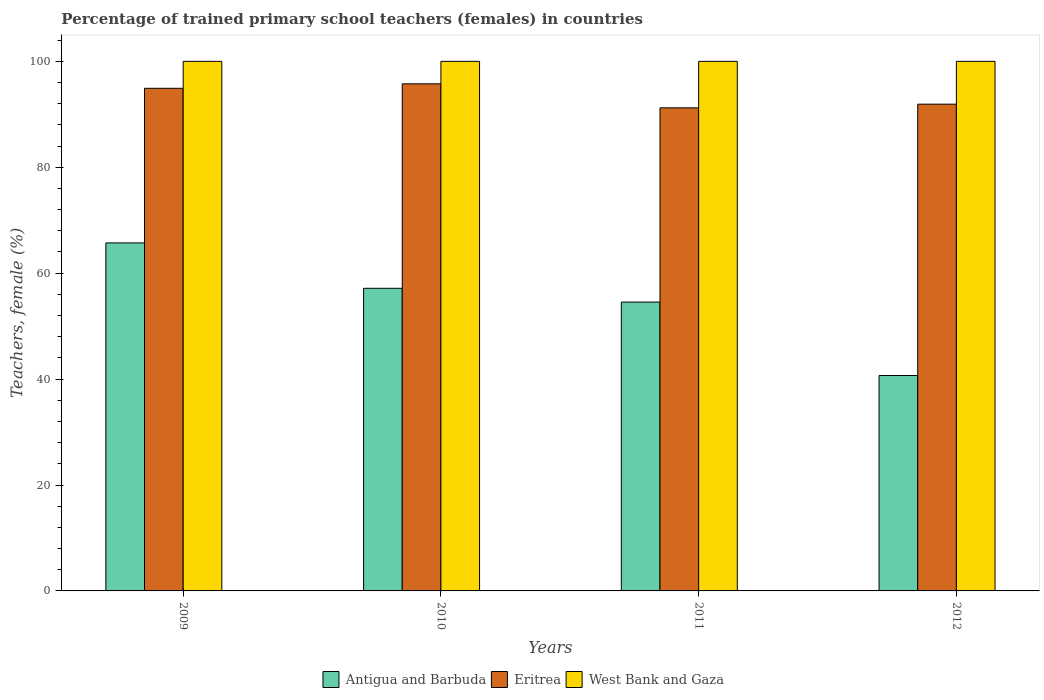How many different coloured bars are there?
Make the answer very short. 3. How many groups of bars are there?
Give a very brief answer. 4. How many bars are there on the 1st tick from the left?
Your answer should be very brief. 3. What is the label of the 1st group of bars from the left?
Your answer should be very brief. 2009. In how many cases, is the number of bars for a given year not equal to the number of legend labels?
Offer a terse response. 0. What is the percentage of trained primary school teachers (females) in Antigua and Barbuda in 2009?
Keep it short and to the point. 65.71. Across all years, what is the maximum percentage of trained primary school teachers (females) in Eritrea?
Offer a very short reply. 95.76. Across all years, what is the minimum percentage of trained primary school teachers (females) in Eritrea?
Give a very brief answer. 91.22. In which year was the percentage of trained primary school teachers (females) in Eritrea minimum?
Provide a short and direct response. 2011. What is the difference between the percentage of trained primary school teachers (females) in Antigua and Barbuda in 2010 and that in 2011?
Offer a very short reply. 2.6. What is the difference between the percentage of trained primary school teachers (females) in Eritrea in 2011 and the percentage of trained primary school teachers (females) in West Bank and Gaza in 2009?
Your response must be concise. -8.78. What is the average percentage of trained primary school teachers (females) in Antigua and Barbuda per year?
Make the answer very short. 54.52. In the year 2012, what is the difference between the percentage of trained primary school teachers (females) in Antigua and Barbuda and percentage of trained primary school teachers (females) in West Bank and Gaza?
Provide a short and direct response. -59.32. What is the ratio of the percentage of trained primary school teachers (females) in West Bank and Gaza in 2011 to that in 2012?
Provide a short and direct response. 1. Is the difference between the percentage of trained primary school teachers (females) in Antigua and Barbuda in 2011 and 2012 greater than the difference between the percentage of trained primary school teachers (females) in West Bank and Gaza in 2011 and 2012?
Your answer should be very brief. Yes. What is the difference between the highest and the second highest percentage of trained primary school teachers (females) in Antigua and Barbuda?
Ensure brevity in your answer.  8.57. What is the difference between the highest and the lowest percentage of trained primary school teachers (females) in Antigua and Barbuda?
Make the answer very short. 25.04. In how many years, is the percentage of trained primary school teachers (females) in Antigua and Barbuda greater than the average percentage of trained primary school teachers (females) in Antigua and Barbuda taken over all years?
Ensure brevity in your answer.  3. What does the 2nd bar from the left in 2010 represents?
Make the answer very short. Eritrea. What does the 1st bar from the right in 2009 represents?
Offer a very short reply. West Bank and Gaza. Is it the case that in every year, the sum of the percentage of trained primary school teachers (females) in West Bank and Gaza and percentage of trained primary school teachers (females) in Antigua and Barbuda is greater than the percentage of trained primary school teachers (females) in Eritrea?
Make the answer very short. Yes. How many bars are there?
Your response must be concise. 12. Are all the bars in the graph horizontal?
Offer a very short reply. No. How many years are there in the graph?
Offer a very short reply. 4. What is the difference between two consecutive major ticks on the Y-axis?
Offer a terse response. 20. Does the graph contain grids?
Give a very brief answer. No. How many legend labels are there?
Give a very brief answer. 3. How are the legend labels stacked?
Your answer should be very brief. Horizontal. What is the title of the graph?
Make the answer very short. Percentage of trained primary school teachers (females) in countries. What is the label or title of the X-axis?
Ensure brevity in your answer.  Years. What is the label or title of the Y-axis?
Make the answer very short. Teachers, female (%). What is the Teachers, female (%) in Antigua and Barbuda in 2009?
Ensure brevity in your answer.  65.71. What is the Teachers, female (%) of Eritrea in 2009?
Your answer should be compact. 94.91. What is the Teachers, female (%) in Antigua and Barbuda in 2010?
Ensure brevity in your answer.  57.14. What is the Teachers, female (%) of Eritrea in 2010?
Provide a short and direct response. 95.76. What is the Teachers, female (%) in Antigua and Barbuda in 2011?
Your response must be concise. 54.55. What is the Teachers, female (%) in Eritrea in 2011?
Provide a succinct answer. 91.22. What is the Teachers, female (%) in West Bank and Gaza in 2011?
Your answer should be compact. 100. What is the Teachers, female (%) in Antigua and Barbuda in 2012?
Your answer should be compact. 40.68. What is the Teachers, female (%) in Eritrea in 2012?
Offer a terse response. 91.91. Across all years, what is the maximum Teachers, female (%) of Antigua and Barbuda?
Offer a very short reply. 65.71. Across all years, what is the maximum Teachers, female (%) of Eritrea?
Provide a succinct answer. 95.76. Across all years, what is the maximum Teachers, female (%) of West Bank and Gaza?
Provide a succinct answer. 100. Across all years, what is the minimum Teachers, female (%) of Antigua and Barbuda?
Make the answer very short. 40.68. Across all years, what is the minimum Teachers, female (%) in Eritrea?
Provide a short and direct response. 91.22. Across all years, what is the minimum Teachers, female (%) of West Bank and Gaza?
Offer a very short reply. 100. What is the total Teachers, female (%) in Antigua and Barbuda in the graph?
Keep it short and to the point. 218.08. What is the total Teachers, female (%) in Eritrea in the graph?
Offer a very short reply. 373.81. What is the total Teachers, female (%) in West Bank and Gaza in the graph?
Your answer should be very brief. 400. What is the difference between the Teachers, female (%) of Antigua and Barbuda in 2009 and that in 2010?
Your answer should be very brief. 8.57. What is the difference between the Teachers, female (%) in Eritrea in 2009 and that in 2010?
Offer a very short reply. -0.85. What is the difference between the Teachers, female (%) in West Bank and Gaza in 2009 and that in 2010?
Offer a very short reply. 0. What is the difference between the Teachers, female (%) in Antigua and Barbuda in 2009 and that in 2011?
Your response must be concise. 11.17. What is the difference between the Teachers, female (%) in Eritrea in 2009 and that in 2011?
Keep it short and to the point. 3.69. What is the difference between the Teachers, female (%) in Antigua and Barbuda in 2009 and that in 2012?
Give a very brief answer. 25.04. What is the difference between the Teachers, female (%) of Eritrea in 2009 and that in 2012?
Make the answer very short. 3. What is the difference between the Teachers, female (%) in Antigua and Barbuda in 2010 and that in 2011?
Provide a succinct answer. 2.6. What is the difference between the Teachers, female (%) in Eritrea in 2010 and that in 2011?
Make the answer very short. 4.54. What is the difference between the Teachers, female (%) of Antigua and Barbuda in 2010 and that in 2012?
Provide a succinct answer. 16.46. What is the difference between the Teachers, female (%) of Eritrea in 2010 and that in 2012?
Offer a very short reply. 3.84. What is the difference between the Teachers, female (%) in West Bank and Gaza in 2010 and that in 2012?
Offer a very short reply. 0. What is the difference between the Teachers, female (%) of Antigua and Barbuda in 2011 and that in 2012?
Your answer should be very brief. 13.87. What is the difference between the Teachers, female (%) of Eritrea in 2011 and that in 2012?
Give a very brief answer. -0.69. What is the difference between the Teachers, female (%) of Antigua and Barbuda in 2009 and the Teachers, female (%) of Eritrea in 2010?
Give a very brief answer. -30.04. What is the difference between the Teachers, female (%) in Antigua and Barbuda in 2009 and the Teachers, female (%) in West Bank and Gaza in 2010?
Make the answer very short. -34.29. What is the difference between the Teachers, female (%) of Eritrea in 2009 and the Teachers, female (%) of West Bank and Gaza in 2010?
Make the answer very short. -5.09. What is the difference between the Teachers, female (%) of Antigua and Barbuda in 2009 and the Teachers, female (%) of Eritrea in 2011?
Provide a short and direct response. -25.51. What is the difference between the Teachers, female (%) in Antigua and Barbuda in 2009 and the Teachers, female (%) in West Bank and Gaza in 2011?
Offer a terse response. -34.29. What is the difference between the Teachers, female (%) in Eritrea in 2009 and the Teachers, female (%) in West Bank and Gaza in 2011?
Your response must be concise. -5.09. What is the difference between the Teachers, female (%) in Antigua and Barbuda in 2009 and the Teachers, female (%) in Eritrea in 2012?
Provide a succinct answer. -26.2. What is the difference between the Teachers, female (%) of Antigua and Barbuda in 2009 and the Teachers, female (%) of West Bank and Gaza in 2012?
Give a very brief answer. -34.29. What is the difference between the Teachers, female (%) of Eritrea in 2009 and the Teachers, female (%) of West Bank and Gaza in 2012?
Keep it short and to the point. -5.09. What is the difference between the Teachers, female (%) of Antigua and Barbuda in 2010 and the Teachers, female (%) of Eritrea in 2011?
Ensure brevity in your answer.  -34.08. What is the difference between the Teachers, female (%) in Antigua and Barbuda in 2010 and the Teachers, female (%) in West Bank and Gaza in 2011?
Give a very brief answer. -42.86. What is the difference between the Teachers, female (%) of Eritrea in 2010 and the Teachers, female (%) of West Bank and Gaza in 2011?
Your answer should be very brief. -4.24. What is the difference between the Teachers, female (%) in Antigua and Barbuda in 2010 and the Teachers, female (%) in Eritrea in 2012?
Offer a terse response. -34.77. What is the difference between the Teachers, female (%) in Antigua and Barbuda in 2010 and the Teachers, female (%) in West Bank and Gaza in 2012?
Give a very brief answer. -42.86. What is the difference between the Teachers, female (%) in Eritrea in 2010 and the Teachers, female (%) in West Bank and Gaza in 2012?
Make the answer very short. -4.24. What is the difference between the Teachers, female (%) in Antigua and Barbuda in 2011 and the Teachers, female (%) in Eritrea in 2012?
Your answer should be compact. -37.37. What is the difference between the Teachers, female (%) of Antigua and Barbuda in 2011 and the Teachers, female (%) of West Bank and Gaza in 2012?
Give a very brief answer. -45.45. What is the difference between the Teachers, female (%) in Eritrea in 2011 and the Teachers, female (%) in West Bank and Gaza in 2012?
Your answer should be very brief. -8.78. What is the average Teachers, female (%) in Antigua and Barbuda per year?
Your answer should be compact. 54.52. What is the average Teachers, female (%) of Eritrea per year?
Your answer should be compact. 93.45. In the year 2009, what is the difference between the Teachers, female (%) in Antigua and Barbuda and Teachers, female (%) in Eritrea?
Keep it short and to the point. -29.2. In the year 2009, what is the difference between the Teachers, female (%) of Antigua and Barbuda and Teachers, female (%) of West Bank and Gaza?
Your response must be concise. -34.29. In the year 2009, what is the difference between the Teachers, female (%) in Eritrea and Teachers, female (%) in West Bank and Gaza?
Your response must be concise. -5.09. In the year 2010, what is the difference between the Teachers, female (%) of Antigua and Barbuda and Teachers, female (%) of Eritrea?
Your answer should be compact. -38.62. In the year 2010, what is the difference between the Teachers, female (%) in Antigua and Barbuda and Teachers, female (%) in West Bank and Gaza?
Ensure brevity in your answer.  -42.86. In the year 2010, what is the difference between the Teachers, female (%) of Eritrea and Teachers, female (%) of West Bank and Gaza?
Keep it short and to the point. -4.24. In the year 2011, what is the difference between the Teachers, female (%) of Antigua and Barbuda and Teachers, female (%) of Eritrea?
Provide a short and direct response. -36.68. In the year 2011, what is the difference between the Teachers, female (%) in Antigua and Barbuda and Teachers, female (%) in West Bank and Gaza?
Your response must be concise. -45.45. In the year 2011, what is the difference between the Teachers, female (%) of Eritrea and Teachers, female (%) of West Bank and Gaza?
Your response must be concise. -8.78. In the year 2012, what is the difference between the Teachers, female (%) in Antigua and Barbuda and Teachers, female (%) in Eritrea?
Make the answer very short. -51.24. In the year 2012, what is the difference between the Teachers, female (%) in Antigua and Barbuda and Teachers, female (%) in West Bank and Gaza?
Offer a terse response. -59.32. In the year 2012, what is the difference between the Teachers, female (%) of Eritrea and Teachers, female (%) of West Bank and Gaza?
Your answer should be very brief. -8.09. What is the ratio of the Teachers, female (%) of Antigua and Barbuda in 2009 to that in 2010?
Your response must be concise. 1.15. What is the ratio of the Teachers, female (%) in West Bank and Gaza in 2009 to that in 2010?
Your answer should be very brief. 1. What is the ratio of the Teachers, female (%) of Antigua and Barbuda in 2009 to that in 2011?
Your response must be concise. 1.2. What is the ratio of the Teachers, female (%) of Eritrea in 2009 to that in 2011?
Offer a very short reply. 1.04. What is the ratio of the Teachers, female (%) of West Bank and Gaza in 2009 to that in 2011?
Your answer should be compact. 1. What is the ratio of the Teachers, female (%) in Antigua and Barbuda in 2009 to that in 2012?
Your response must be concise. 1.62. What is the ratio of the Teachers, female (%) of Eritrea in 2009 to that in 2012?
Your answer should be compact. 1.03. What is the ratio of the Teachers, female (%) of Antigua and Barbuda in 2010 to that in 2011?
Your response must be concise. 1.05. What is the ratio of the Teachers, female (%) in Eritrea in 2010 to that in 2011?
Your answer should be compact. 1.05. What is the ratio of the Teachers, female (%) of West Bank and Gaza in 2010 to that in 2011?
Give a very brief answer. 1. What is the ratio of the Teachers, female (%) in Antigua and Barbuda in 2010 to that in 2012?
Give a very brief answer. 1.4. What is the ratio of the Teachers, female (%) in Eritrea in 2010 to that in 2012?
Ensure brevity in your answer.  1.04. What is the ratio of the Teachers, female (%) in West Bank and Gaza in 2010 to that in 2012?
Ensure brevity in your answer.  1. What is the ratio of the Teachers, female (%) of Antigua and Barbuda in 2011 to that in 2012?
Your response must be concise. 1.34. What is the difference between the highest and the second highest Teachers, female (%) of Antigua and Barbuda?
Offer a terse response. 8.57. What is the difference between the highest and the second highest Teachers, female (%) of Eritrea?
Provide a succinct answer. 0.85. What is the difference between the highest and the second highest Teachers, female (%) in West Bank and Gaza?
Your response must be concise. 0. What is the difference between the highest and the lowest Teachers, female (%) of Antigua and Barbuda?
Keep it short and to the point. 25.04. What is the difference between the highest and the lowest Teachers, female (%) in Eritrea?
Make the answer very short. 4.54. 